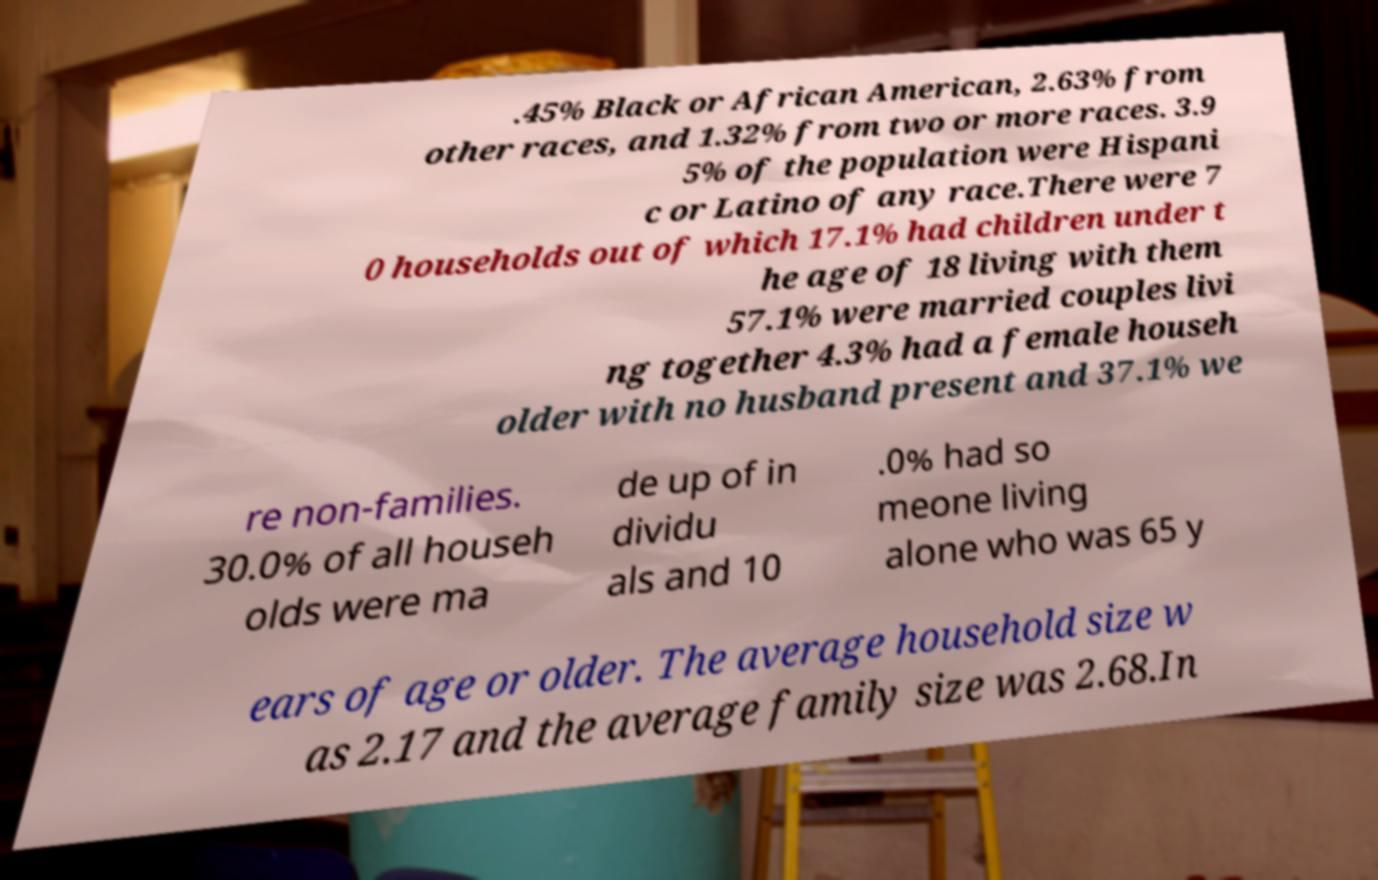Could you extract and type out the text from this image? .45% Black or African American, 2.63% from other races, and 1.32% from two or more races. 3.9 5% of the population were Hispani c or Latino of any race.There were 7 0 households out of which 17.1% had children under t he age of 18 living with them 57.1% were married couples livi ng together 4.3% had a female househ older with no husband present and 37.1% we re non-families. 30.0% of all househ olds were ma de up of in dividu als and 10 .0% had so meone living alone who was 65 y ears of age or older. The average household size w as 2.17 and the average family size was 2.68.In 